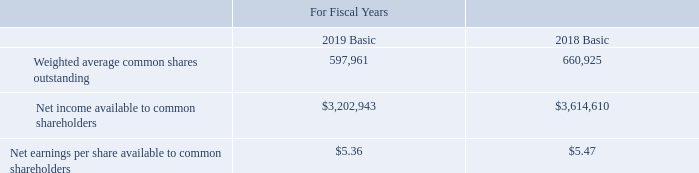3. EARNINGS PER SHARE:
Basic earnings per share available to common shareholders is calculated by dividing net income less preferred stock dividend requirements by the weighted average common shares outstanding for each period. Diluted earnings per share available to common shareholders is calculated by dividing income from operations less preferred stock dividend requirements (when anti-dilutive) by the sum of the weighted average common shares outstanding and the weighted average dilutive equity awards.
How is basic earnings per share available to common shareholders calculated? Dividing net income less preferred stock dividend requirements by the weighted average common shares outstanding for each period. How is diluted earnings per share available to common shareholders calculated? Dividing income from operations less preferred stock dividend requirements (when anti-dilutive) by the sum of the weighted average common shares outstanding and the weighted average dilutive equity awards. What are the respective weighted average basic common shares outstanding for fiscal years 2018 and 2019? 660,925, 597,961. What is the percentage change in the weighted average basic common shares outstanding between 2018 and 2019?
Answer scale should be: percent. (597,961 - 660,925)/660,925 
Answer: -9.53. What is the percentage change in the net income available to common shareholders between 2018 and 2019?
Answer scale should be: percent. (3,202,943 - 3,614,610)/3,614,610 
Answer: -11.39. What is the average net earnings per share available to common basic shareholders in 2018 and 2019? (5.47 + 5.36)/2 
Answer: 5.42. 